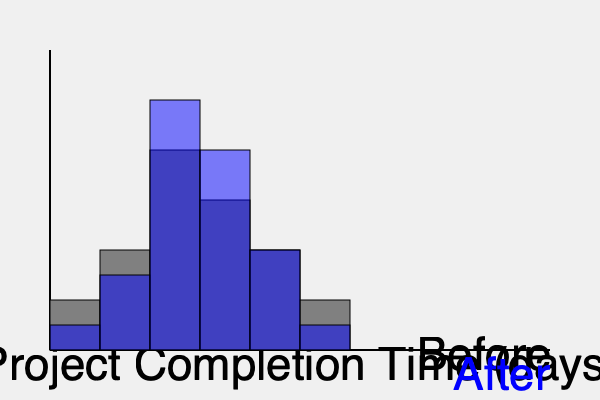As a team leader who values the researcher's contributions, how would you interpret the changes in project completion times after implementing new team strategies, based on the histograms provided? To interpret the changes in project completion times, we need to analyze the two histograms:

1. Shape: 
   - Before: The distribution is roughly symmetric, with a peak in the middle.
   - After: The distribution is more right-skewed, with a higher peak shifted slightly to the left.

2. Central tendency:
   - The mode (highest bar) has shifted to a lower completion time after implementing new strategies.
   - The median (middle value) appears to have decreased as well.

3. Spread:
   - The range of completion times seems to have decreased slightly after implementation.
   - There are fewer projects in the longest completion time category.

4. Frequency:
   - The highest frequency has increased after implementation, suggesting more projects are completed within a similar timeframe.

5. Overall shift:
   - There is a general shift towards shorter completion times, with more projects finishing in less time.

Interpretation:
The new team strategies appear to have had a positive impact on project completion times. More projects are being completed in less time, and there's a reduction in the number of projects taking the longest to complete. This suggests improved efficiency and consistency in project execution.

As a team leader, you would want to:
1. Acknowledge the research team's efforts in developing these strategies.
2. Encourage the team to present these findings, highlighting the positive impact.
3. Discuss any challenges or areas for further improvement.
4. Consider applying similar strategies to other areas of the team's work.
Answer: Improved efficiency: shorter completion times, higher consistency, positive impact of new strategies. 